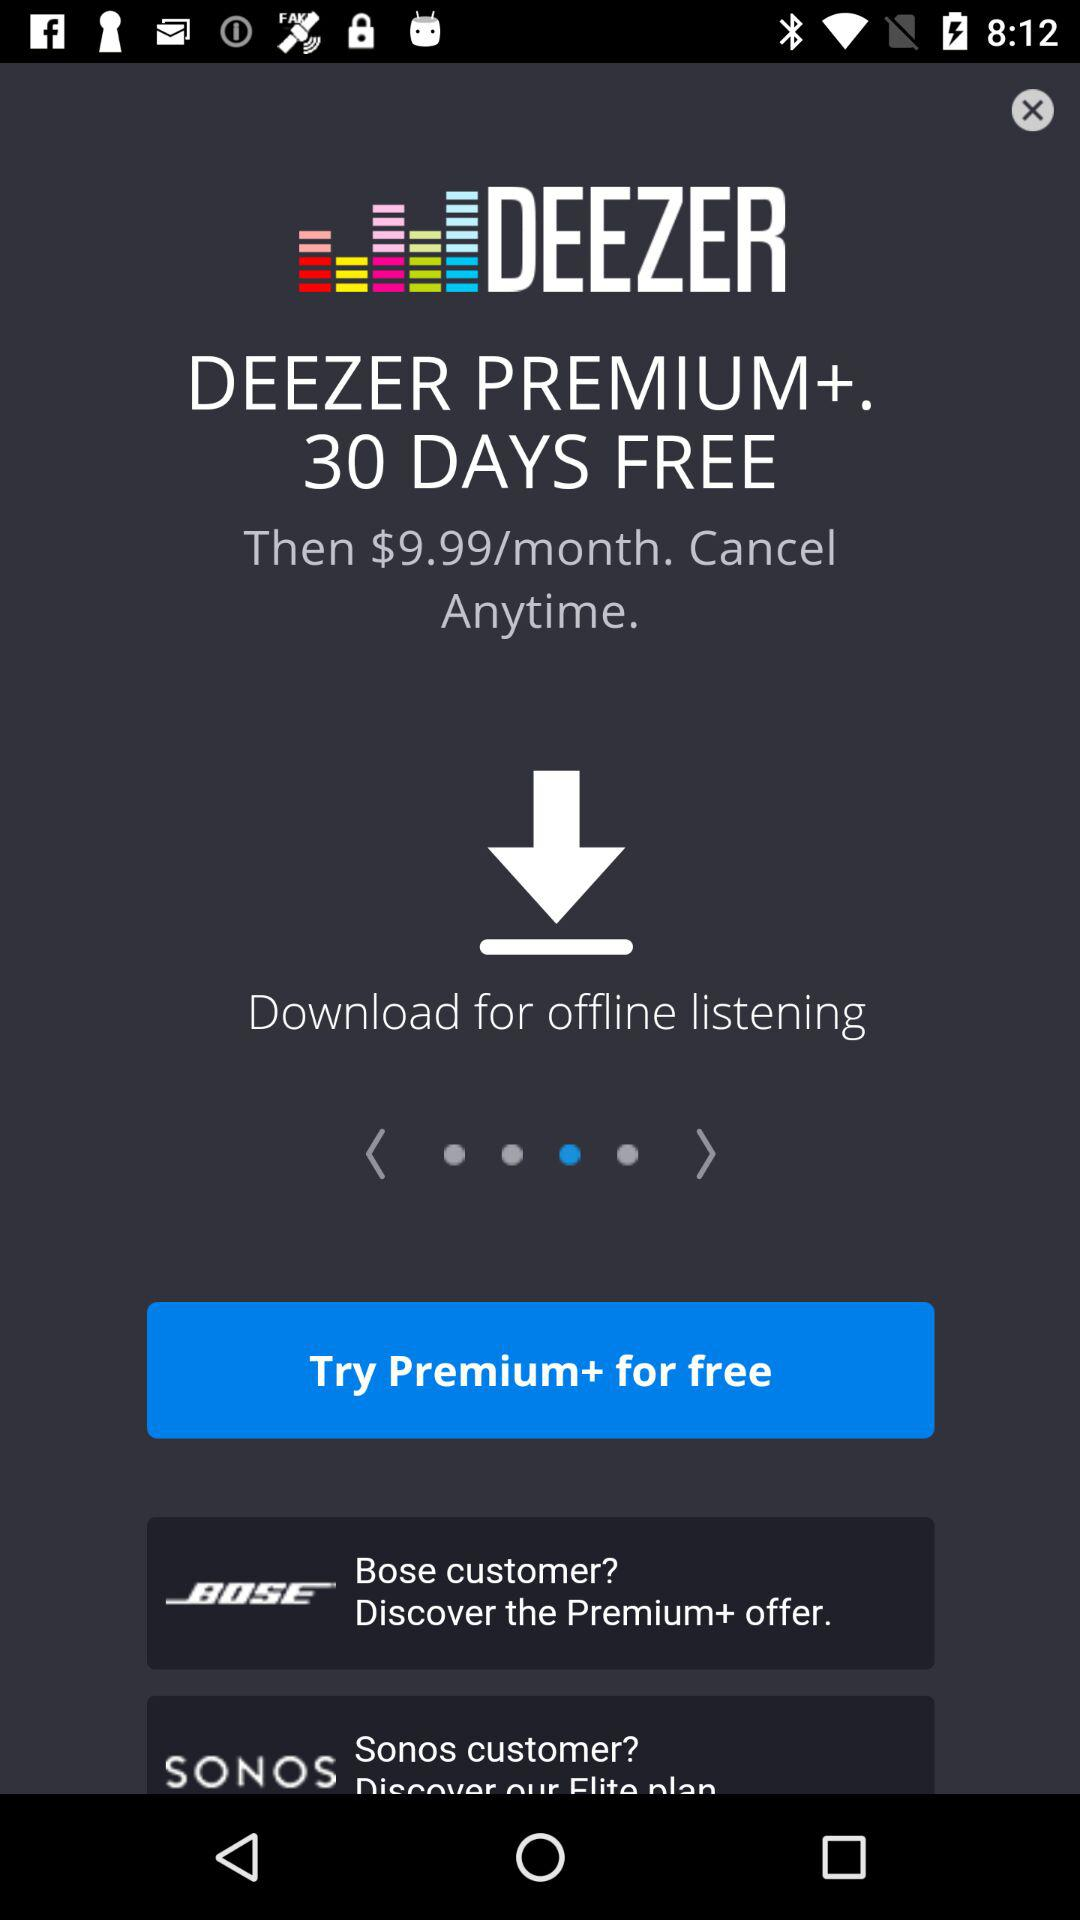What is the name of the application? The name of the application is "DEEZER". 